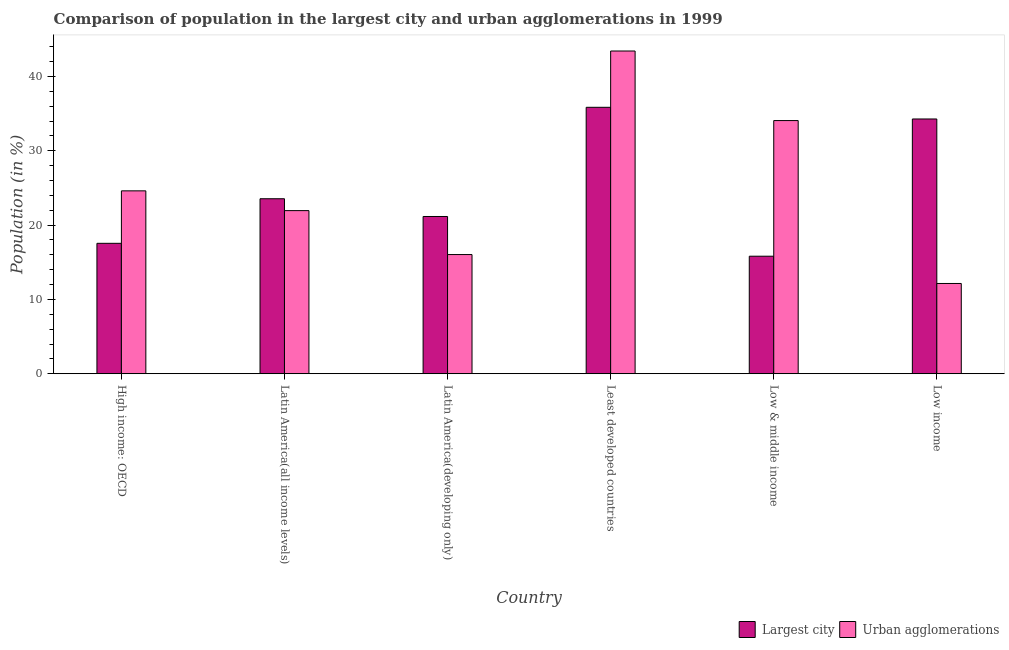How many different coloured bars are there?
Provide a short and direct response. 2. How many groups of bars are there?
Keep it short and to the point. 6. Are the number of bars per tick equal to the number of legend labels?
Give a very brief answer. Yes. Are the number of bars on each tick of the X-axis equal?
Offer a very short reply. Yes. How many bars are there on the 5th tick from the left?
Offer a terse response. 2. What is the label of the 6th group of bars from the left?
Give a very brief answer. Low income. In how many cases, is the number of bars for a given country not equal to the number of legend labels?
Your response must be concise. 0. What is the population in the largest city in Latin America(developing only)?
Ensure brevity in your answer.  21.16. Across all countries, what is the maximum population in the largest city?
Ensure brevity in your answer.  35.85. Across all countries, what is the minimum population in urban agglomerations?
Keep it short and to the point. 12.15. In which country was the population in the largest city maximum?
Provide a short and direct response. Least developed countries. In which country was the population in urban agglomerations minimum?
Your response must be concise. Low income. What is the total population in the largest city in the graph?
Make the answer very short. 148.18. What is the difference between the population in urban agglomerations in Latin America(all income levels) and that in Low & middle income?
Make the answer very short. -12.12. What is the difference between the population in the largest city in Latin America(all income levels) and the population in urban agglomerations in Latin America(developing only)?
Your answer should be very brief. 7.51. What is the average population in the largest city per country?
Offer a very short reply. 24.7. What is the difference between the population in the largest city and population in urban agglomerations in Low income?
Provide a short and direct response. 22.13. What is the ratio of the population in the largest city in Latin America(all income levels) to that in Latin America(developing only)?
Provide a succinct answer. 1.11. Is the population in the largest city in High income: OECD less than that in Low income?
Your answer should be compact. Yes. What is the difference between the highest and the second highest population in the largest city?
Ensure brevity in your answer.  1.57. What is the difference between the highest and the lowest population in the largest city?
Your answer should be compact. 20.04. In how many countries, is the population in the largest city greater than the average population in the largest city taken over all countries?
Your answer should be very brief. 2. Is the sum of the population in urban agglomerations in Least developed countries and Low & middle income greater than the maximum population in the largest city across all countries?
Offer a terse response. Yes. What does the 1st bar from the left in Low income represents?
Provide a succinct answer. Largest city. What does the 1st bar from the right in Latin America(all income levels) represents?
Your answer should be very brief. Urban agglomerations. How many bars are there?
Provide a succinct answer. 12. Are all the bars in the graph horizontal?
Offer a terse response. No. How many countries are there in the graph?
Provide a succinct answer. 6. Are the values on the major ticks of Y-axis written in scientific E-notation?
Give a very brief answer. No. Does the graph contain any zero values?
Keep it short and to the point. No. Does the graph contain grids?
Ensure brevity in your answer.  No. Where does the legend appear in the graph?
Make the answer very short. Bottom right. How are the legend labels stacked?
Provide a succinct answer. Horizontal. What is the title of the graph?
Make the answer very short. Comparison of population in the largest city and urban agglomerations in 1999. Does "Total Population" appear as one of the legend labels in the graph?
Keep it short and to the point. No. What is the label or title of the X-axis?
Offer a very short reply. Country. What is the label or title of the Y-axis?
Offer a terse response. Population (in %). What is the Population (in %) of Largest city in High income: OECD?
Your response must be concise. 17.55. What is the Population (in %) of Urban agglomerations in High income: OECD?
Provide a succinct answer. 24.61. What is the Population (in %) of Largest city in Latin America(all income levels)?
Make the answer very short. 23.54. What is the Population (in %) of Urban agglomerations in Latin America(all income levels)?
Offer a very short reply. 21.95. What is the Population (in %) of Largest city in Latin America(developing only)?
Your response must be concise. 21.16. What is the Population (in %) in Urban agglomerations in Latin America(developing only)?
Provide a short and direct response. 16.03. What is the Population (in %) in Largest city in Least developed countries?
Ensure brevity in your answer.  35.85. What is the Population (in %) of Urban agglomerations in Least developed countries?
Make the answer very short. 43.42. What is the Population (in %) in Largest city in Low & middle income?
Offer a terse response. 15.81. What is the Population (in %) of Urban agglomerations in Low & middle income?
Your response must be concise. 34.06. What is the Population (in %) in Largest city in Low income?
Make the answer very short. 34.28. What is the Population (in %) in Urban agglomerations in Low income?
Ensure brevity in your answer.  12.15. Across all countries, what is the maximum Population (in %) in Largest city?
Your answer should be compact. 35.85. Across all countries, what is the maximum Population (in %) in Urban agglomerations?
Your response must be concise. 43.42. Across all countries, what is the minimum Population (in %) of Largest city?
Offer a terse response. 15.81. Across all countries, what is the minimum Population (in %) in Urban agglomerations?
Provide a short and direct response. 12.15. What is the total Population (in %) of Largest city in the graph?
Your answer should be very brief. 148.18. What is the total Population (in %) of Urban agglomerations in the graph?
Your response must be concise. 152.22. What is the difference between the Population (in %) of Largest city in High income: OECD and that in Latin America(all income levels)?
Give a very brief answer. -6. What is the difference between the Population (in %) of Urban agglomerations in High income: OECD and that in Latin America(all income levels)?
Keep it short and to the point. 2.66. What is the difference between the Population (in %) in Largest city in High income: OECD and that in Latin America(developing only)?
Provide a short and direct response. -3.61. What is the difference between the Population (in %) in Urban agglomerations in High income: OECD and that in Latin America(developing only)?
Your response must be concise. 8.57. What is the difference between the Population (in %) of Largest city in High income: OECD and that in Least developed countries?
Offer a very short reply. -18.3. What is the difference between the Population (in %) of Urban agglomerations in High income: OECD and that in Least developed countries?
Make the answer very short. -18.81. What is the difference between the Population (in %) of Largest city in High income: OECD and that in Low & middle income?
Provide a succinct answer. 1.73. What is the difference between the Population (in %) of Urban agglomerations in High income: OECD and that in Low & middle income?
Give a very brief answer. -9.46. What is the difference between the Population (in %) in Largest city in High income: OECD and that in Low income?
Give a very brief answer. -16.73. What is the difference between the Population (in %) in Urban agglomerations in High income: OECD and that in Low income?
Keep it short and to the point. 12.46. What is the difference between the Population (in %) of Largest city in Latin America(all income levels) and that in Latin America(developing only)?
Give a very brief answer. 2.39. What is the difference between the Population (in %) in Urban agglomerations in Latin America(all income levels) and that in Latin America(developing only)?
Keep it short and to the point. 5.91. What is the difference between the Population (in %) of Largest city in Latin America(all income levels) and that in Least developed countries?
Provide a short and direct response. -12.3. What is the difference between the Population (in %) in Urban agglomerations in Latin America(all income levels) and that in Least developed countries?
Provide a short and direct response. -21.48. What is the difference between the Population (in %) of Largest city in Latin America(all income levels) and that in Low & middle income?
Give a very brief answer. 7.73. What is the difference between the Population (in %) of Urban agglomerations in Latin America(all income levels) and that in Low & middle income?
Offer a very short reply. -12.12. What is the difference between the Population (in %) in Largest city in Latin America(all income levels) and that in Low income?
Provide a succinct answer. -10.73. What is the difference between the Population (in %) in Urban agglomerations in Latin America(all income levels) and that in Low income?
Your answer should be very brief. 9.8. What is the difference between the Population (in %) in Largest city in Latin America(developing only) and that in Least developed countries?
Provide a short and direct response. -14.69. What is the difference between the Population (in %) of Urban agglomerations in Latin America(developing only) and that in Least developed countries?
Provide a short and direct response. -27.39. What is the difference between the Population (in %) of Largest city in Latin America(developing only) and that in Low & middle income?
Your response must be concise. 5.35. What is the difference between the Population (in %) in Urban agglomerations in Latin America(developing only) and that in Low & middle income?
Provide a succinct answer. -18.03. What is the difference between the Population (in %) in Largest city in Latin America(developing only) and that in Low income?
Make the answer very short. -13.12. What is the difference between the Population (in %) of Urban agglomerations in Latin America(developing only) and that in Low income?
Provide a succinct answer. 3.89. What is the difference between the Population (in %) of Largest city in Least developed countries and that in Low & middle income?
Provide a short and direct response. 20.04. What is the difference between the Population (in %) of Urban agglomerations in Least developed countries and that in Low & middle income?
Your answer should be compact. 9.36. What is the difference between the Population (in %) in Largest city in Least developed countries and that in Low income?
Your answer should be compact. 1.57. What is the difference between the Population (in %) of Urban agglomerations in Least developed countries and that in Low income?
Offer a very short reply. 31.28. What is the difference between the Population (in %) of Largest city in Low & middle income and that in Low income?
Offer a terse response. -18.47. What is the difference between the Population (in %) of Urban agglomerations in Low & middle income and that in Low income?
Provide a succinct answer. 21.92. What is the difference between the Population (in %) of Largest city in High income: OECD and the Population (in %) of Urban agglomerations in Latin America(all income levels)?
Give a very brief answer. -4.4. What is the difference between the Population (in %) of Largest city in High income: OECD and the Population (in %) of Urban agglomerations in Latin America(developing only)?
Offer a very short reply. 1.51. What is the difference between the Population (in %) of Largest city in High income: OECD and the Population (in %) of Urban agglomerations in Least developed countries?
Your answer should be very brief. -25.87. What is the difference between the Population (in %) of Largest city in High income: OECD and the Population (in %) of Urban agglomerations in Low & middle income?
Offer a very short reply. -16.52. What is the difference between the Population (in %) in Largest city in High income: OECD and the Population (in %) in Urban agglomerations in Low income?
Ensure brevity in your answer.  5.4. What is the difference between the Population (in %) of Largest city in Latin America(all income levels) and the Population (in %) of Urban agglomerations in Latin America(developing only)?
Offer a very short reply. 7.51. What is the difference between the Population (in %) in Largest city in Latin America(all income levels) and the Population (in %) in Urban agglomerations in Least developed countries?
Your answer should be compact. -19.88. What is the difference between the Population (in %) in Largest city in Latin America(all income levels) and the Population (in %) in Urban agglomerations in Low & middle income?
Give a very brief answer. -10.52. What is the difference between the Population (in %) in Largest city in Latin America(all income levels) and the Population (in %) in Urban agglomerations in Low income?
Make the answer very short. 11.4. What is the difference between the Population (in %) in Largest city in Latin America(developing only) and the Population (in %) in Urban agglomerations in Least developed countries?
Your answer should be very brief. -22.26. What is the difference between the Population (in %) in Largest city in Latin America(developing only) and the Population (in %) in Urban agglomerations in Low & middle income?
Ensure brevity in your answer.  -12.91. What is the difference between the Population (in %) of Largest city in Latin America(developing only) and the Population (in %) of Urban agglomerations in Low income?
Give a very brief answer. 9.01. What is the difference between the Population (in %) in Largest city in Least developed countries and the Population (in %) in Urban agglomerations in Low & middle income?
Your answer should be compact. 1.79. What is the difference between the Population (in %) of Largest city in Least developed countries and the Population (in %) of Urban agglomerations in Low income?
Your response must be concise. 23.7. What is the difference between the Population (in %) of Largest city in Low & middle income and the Population (in %) of Urban agglomerations in Low income?
Give a very brief answer. 3.67. What is the average Population (in %) in Largest city per country?
Offer a terse response. 24.7. What is the average Population (in %) in Urban agglomerations per country?
Your response must be concise. 25.37. What is the difference between the Population (in %) in Largest city and Population (in %) in Urban agglomerations in High income: OECD?
Offer a terse response. -7.06. What is the difference between the Population (in %) of Largest city and Population (in %) of Urban agglomerations in Latin America(all income levels)?
Make the answer very short. 1.6. What is the difference between the Population (in %) of Largest city and Population (in %) of Urban agglomerations in Latin America(developing only)?
Offer a terse response. 5.12. What is the difference between the Population (in %) of Largest city and Population (in %) of Urban agglomerations in Least developed countries?
Offer a very short reply. -7.57. What is the difference between the Population (in %) of Largest city and Population (in %) of Urban agglomerations in Low & middle income?
Offer a very short reply. -18.25. What is the difference between the Population (in %) in Largest city and Population (in %) in Urban agglomerations in Low income?
Give a very brief answer. 22.13. What is the ratio of the Population (in %) in Largest city in High income: OECD to that in Latin America(all income levels)?
Provide a succinct answer. 0.75. What is the ratio of the Population (in %) in Urban agglomerations in High income: OECD to that in Latin America(all income levels)?
Give a very brief answer. 1.12. What is the ratio of the Population (in %) in Largest city in High income: OECD to that in Latin America(developing only)?
Offer a terse response. 0.83. What is the ratio of the Population (in %) of Urban agglomerations in High income: OECD to that in Latin America(developing only)?
Your answer should be compact. 1.53. What is the ratio of the Population (in %) of Largest city in High income: OECD to that in Least developed countries?
Provide a succinct answer. 0.49. What is the ratio of the Population (in %) in Urban agglomerations in High income: OECD to that in Least developed countries?
Offer a very short reply. 0.57. What is the ratio of the Population (in %) of Largest city in High income: OECD to that in Low & middle income?
Your answer should be very brief. 1.11. What is the ratio of the Population (in %) of Urban agglomerations in High income: OECD to that in Low & middle income?
Your answer should be compact. 0.72. What is the ratio of the Population (in %) in Largest city in High income: OECD to that in Low income?
Offer a very short reply. 0.51. What is the ratio of the Population (in %) in Urban agglomerations in High income: OECD to that in Low income?
Give a very brief answer. 2.03. What is the ratio of the Population (in %) of Largest city in Latin America(all income levels) to that in Latin America(developing only)?
Your answer should be compact. 1.11. What is the ratio of the Population (in %) in Urban agglomerations in Latin America(all income levels) to that in Latin America(developing only)?
Provide a short and direct response. 1.37. What is the ratio of the Population (in %) in Largest city in Latin America(all income levels) to that in Least developed countries?
Give a very brief answer. 0.66. What is the ratio of the Population (in %) in Urban agglomerations in Latin America(all income levels) to that in Least developed countries?
Your response must be concise. 0.51. What is the ratio of the Population (in %) of Largest city in Latin America(all income levels) to that in Low & middle income?
Offer a very short reply. 1.49. What is the ratio of the Population (in %) of Urban agglomerations in Latin America(all income levels) to that in Low & middle income?
Your answer should be compact. 0.64. What is the ratio of the Population (in %) of Largest city in Latin America(all income levels) to that in Low income?
Offer a terse response. 0.69. What is the ratio of the Population (in %) of Urban agglomerations in Latin America(all income levels) to that in Low income?
Keep it short and to the point. 1.81. What is the ratio of the Population (in %) in Largest city in Latin America(developing only) to that in Least developed countries?
Your response must be concise. 0.59. What is the ratio of the Population (in %) in Urban agglomerations in Latin America(developing only) to that in Least developed countries?
Your answer should be compact. 0.37. What is the ratio of the Population (in %) of Largest city in Latin America(developing only) to that in Low & middle income?
Give a very brief answer. 1.34. What is the ratio of the Population (in %) of Urban agglomerations in Latin America(developing only) to that in Low & middle income?
Give a very brief answer. 0.47. What is the ratio of the Population (in %) of Largest city in Latin America(developing only) to that in Low income?
Provide a short and direct response. 0.62. What is the ratio of the Population (in %) in Urban agglomerations in Latin America(developing only) to that in Low income?
Offer a very short reply. 1.32. What is the ratio of the Population (in %) of Largest city in Least developed countries to that in Low & middle income?
Offer a very short reply. 2.27. What is the ratio of the Population (in %) of Urban agglomerations in Least developed countries to that in Low & middle income?
Provide a short and direct response. 1.27. What is the ratio of the Population (in %) of Largest city in Least developed countries to that in Low income?
Your answer should be compact. 1.05. What is the ratio of the Population (in %) of Urban agglomerations in Least developed countries to that in Low income?
Provide a short and direct response. 3.58. What is the ratio of the Population (in %) in Largest city in Low & middle income to that in Low income?
Offer a very short reply. 0.46. What is the ratio of the Population (in %) of Urban agglomerations in Low & middle income to that in Low income?
Offer a terse response. 2.8. What is the difference between the highest and the second highest Population (in %) of Largest city?
Give a very brief answer. 1.57. What is the difference between the highest and the second highest Population (in %) in Urban agglomerations?
Offer a very short reply. 9.36. What is the difference between the highest and the lowest Population (in %) of Largest city?
Offer a very short reply. 20.04. What is the difference between the highest and the lowest Population (in %) of Urban agglomerations?
Provide a short and direct response. 31.28. 